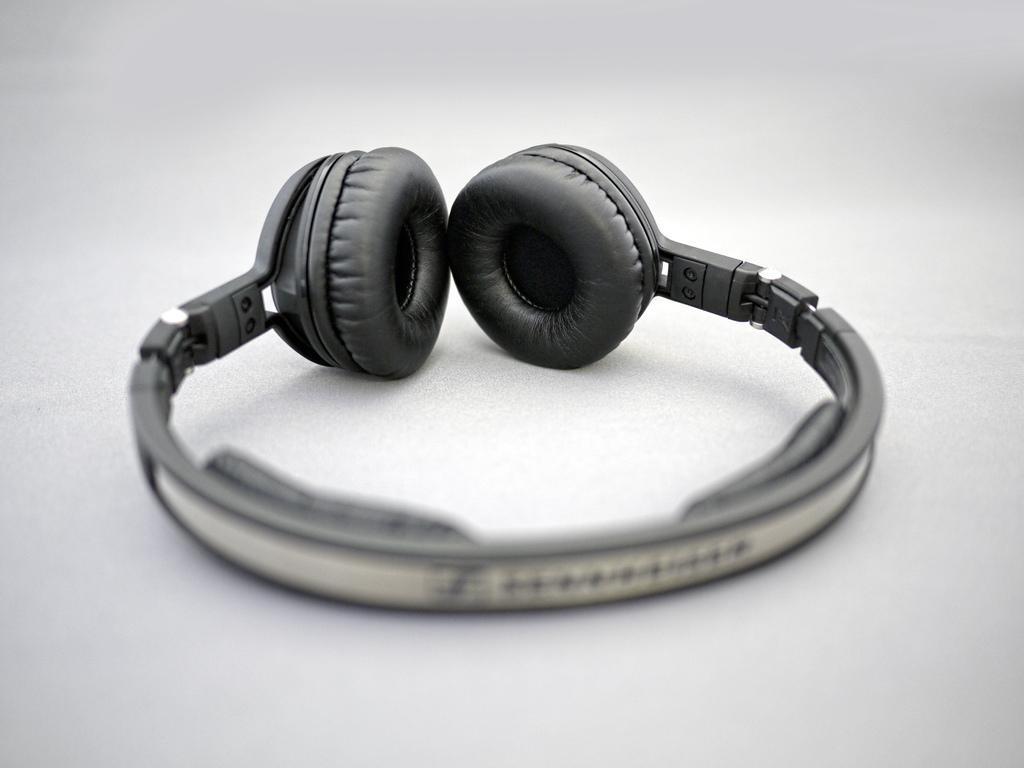How would you summarize this image in a sentence or two? In the picture I can see the headset. 